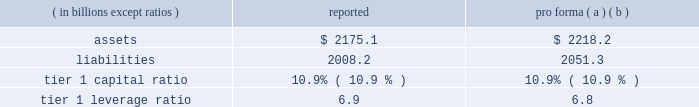Notes to consolidated financial statements 192 jpmorgan chase & co .
/ 2008 annual report consolidation analysis the multi-seller conduits administered by the firm were not consoli- dated at december 31 , 2008 and 2007 , because each conduit had issued expected loss notes ( 201celns 201d ) , the holders of which are com- mitted to absorbing the majority of the expected loss of each respective conduit .
Implied support the firm did not have and continues not to have any intent to pro- tect any eln holders from potential losses on any of the conduits 2019 holdings and has no plans to remove any assets from any conduit unless required to do so in its role as administrator .
Should such a transfer occur , the firm would allocate losses on such assets between itself and the eln holders in accordance with the terms of the applicable eln .
Expected loss modeling in determining the primary beneficiary of the conduits the firm uses a monte carlo 2013based model to estimate the expected losses of each of the conduits and considers the relative rights and obliga- tions of each of the variable interest holders .
The firm 2019s expected loss modeling treats all variable interests , other than the elns , as its own to determine consolidation .
The variability to be considered in the modeling of expected losses is based on the design of the enti- ty .
The firm 2019s traditional multi-seller conduits are designed to pass credit risk , not liquidity risk , to its variable interest holders , as the assets are intended to be held in the conduit for the longer term .
Under fin 46 ( r ) , the firm is required to run the monte carlo-based expected loss model each time a reconsideration event occurs .
In applying this guidance to the conduits , the following events , are considered to be reconsideration events , as they could affect the determination of the primary beneficiary of the conduits : 2022 new deals , including the issuance of new or additional variable interests ( credit support , liquidity facilities , etc ) ; 2022 changes in usage , including the change in the level of outstand- ing variable interests ( credit support , liquidity facilities , etc ) ; 2022 modifications of asset purchase agreements ; and 2022 sales of interests held by the primary beneficiary .
From an operational perspective , the firm does not run its monte carlo-based expected loss model every time there is a reconsideration event due to the frequency of their occurrence .
Instead , the firm runs its expected loss model each quarter and includes a growth assump- tion for each conduit to ensure that a sufficient amount of elns exists for each conduit at any point during the quarter .
As part of its normal quarterly modeling , the firm updates , when applicable , the inputs and assumptions used in the expected loss model .
Specifically , risk ratings and loss given default assumptions are continually updated .
The total amount of expected loss notes out- standing at december 31 , 2008 and 2007 , were $ 136 million and $ 130 million , respectively .
Management has concluded that the model assumptions used were reflective of market participants 2019 assumptions and appropriately considered the probability of changes to risk ratings and loss given defaults .
Qualitative considerations the multi-seller conduits are primarily designed to provide an effi- cient means for clients to access the commercial paper market .
The firm believes the conduits effectively disperse risk among all parties and that the preponderance of the economic risk in the firm 2019s multi- seller conduits is not held by jpmorgan chase .
Consolidated sensitivity analysis on capital the table below shows the impact on the firm 2019s reported assets , lia- bilities , tier 1 capital ratio and tier 1 leverage ratio if the firm were required to consolidate all of the multi-seller conduits that it admin- isters at their current carrying value .
December 31 , 2008 ( in billions , except ratios ) reported pro forma ( a ) ( b ) .
( a ) the table shows the impact of consolidating the assets and liabilities of the multi- seller conduits at their current carrying value ; as such , there would be no income statement or capital impact at the date of consolidation .
If the firm were required to consolidate the assets and liabilities of the conduits at fair value , the tier 1 capital ratio would be approximately 10.8% ( 10.8 % ) .
The fair value of the assets is primarily based upon pricing for comparable transactions .
The fair value of these assets could change significantly because the pricing of conduit transactions is renegotiated with the client , generally , on an annual basis and due to changes in current market conditions .
( b ) consolidation is assumed to occur on the first day of the quarter , at the quarter-end levels , in order to provide a meaningful adjustment to average assets in the denomi- nator of the leverage ratio .
The firm could fund purchases of assets from vies should it become necessary .
2007 activity in july 2007 , a reverse repurchase agreement collateralized by prime residential mortgages held by a firm-administered multi-seller conduit was put to jpmorgan chase under its deal-specific liquidity facility .
The asset was transferred to and recorded by jpmorgan chase at its par value based on the fair value of the collateral that supported the reverse repurchase agreement .
During the fourth quarter of 2007 , additional information regarding the value of the collateral , including performance statistics , resulted in the determi- nation by the firm that the fair value of the collateral was impaired .
Impairment losses were allocated to the eln holder ( the party that absorbs the majority of the expected loss from the conduit ) in accor- dance with the contractual provisions of the eln note .
On october 29 , 2007 , certain structured cdo assets originated in the second quarter of 2007 and backed by subprime mortgages were transferred to the firm from two firm-administered multi-seller conduits .
It became clear in october that commercial paper investors and rating agencies were becoming increasingly concerned about cdo assets backed by subprime mortgage exposures .
Because of these concerns , and to ensure the continuing viability of the two conduits as financing vehicles for clients and as investment alternatives for commercial paper investors , the firm , in its role as administrator , transferred the cdo assets out of the multi-seller con- duits .
The structured cdo assets were transferred to the firm at .
In 2008 what was the firms reported debt to the assets ratio? 
Computations: (2008.2 / 2175.1)
Answer: 0.92327. 